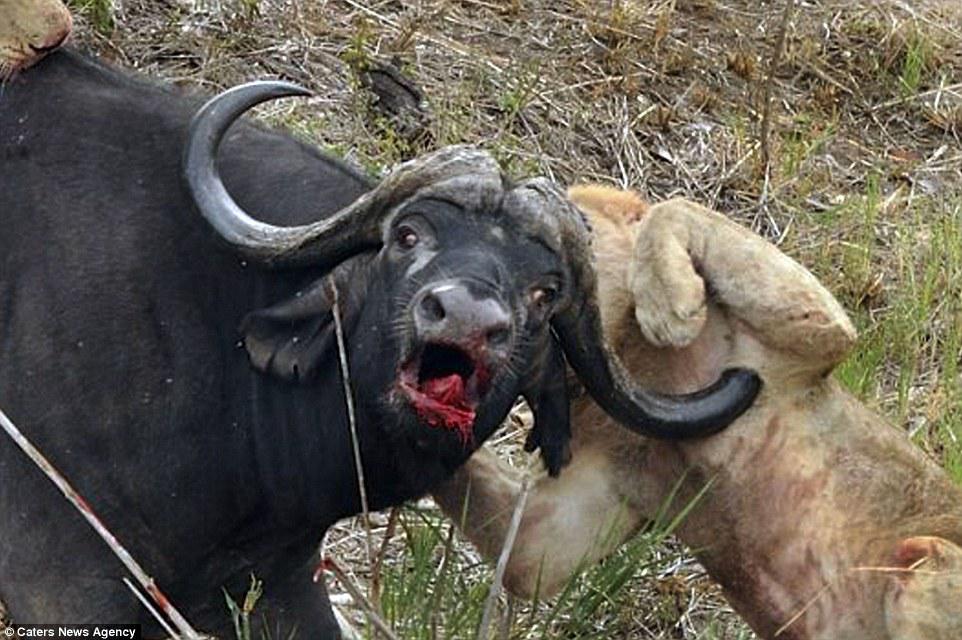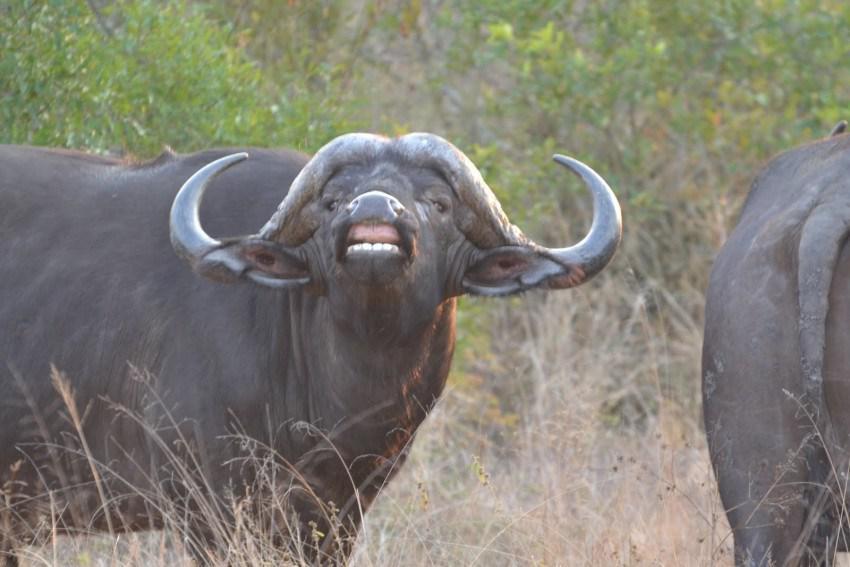The first image is the image on the left, the second image is the image on the right. Considering the images on both sides, is "The animal in the image on the left is looking into the camera." valid? Answer yes or no. Yes. 